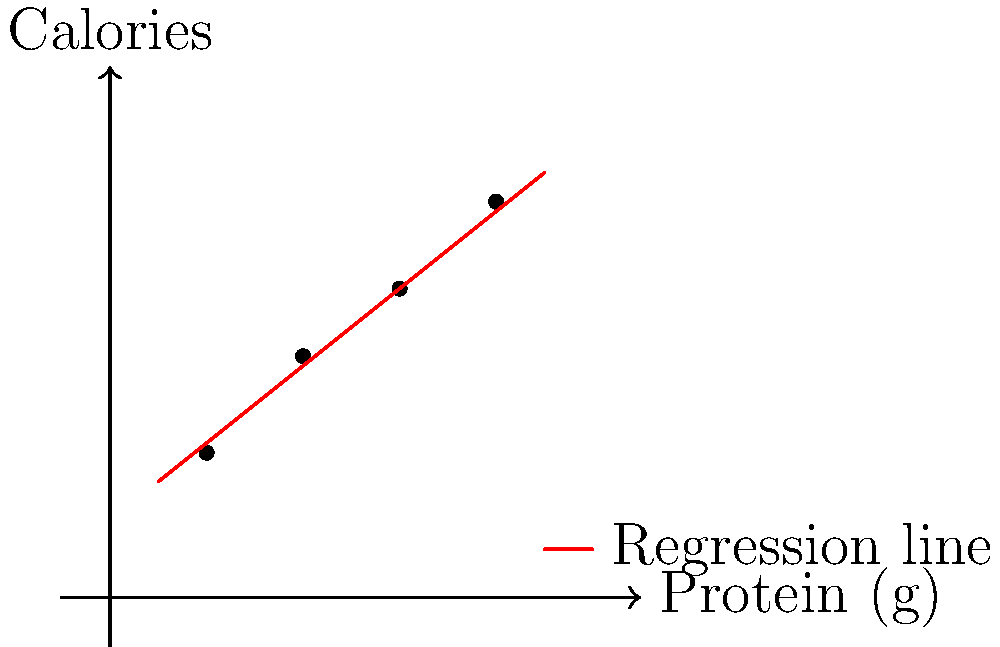Based on the scatter plot showing the relationship between protein content and calorie count in quick breakfast meals, if a new breakfast option contains 3.5g of protein, what would be its estimated calorie content according to the linear regression model? To estimate the calorie content for a breakfast with 3.5g of protein, we'll follow these steps:

1. Observe the linear relationship in the scatter plot.
2. Identify two points on the regression line:
   - At x=1, y≈1.5
   - At x=4, y≈4.1
3. Calculate the slope (m) of the regression line:
   $m = \frac{y_2 - y_1}{x_2 - x_1} = \frac{4.1 - 1.5}{4 - 1} = \frac{2.6}{3} ≈ 0.867$
4. Use the point-slope form of a line: $y - y_1 = m(x - x_1)$
   Using the point (1, 1.5): $y - 1.5 = 0.867(x - 1)$
5. Simplify to get the equation of the line:
   $y = 0.867x + 0.633$
6. Plug in x = 3.5 to estimate the calorie content:
   $y = 0.867(3.5) + 0.633 = 3.0345 + 0.633 = 3.6675$

Therefore, the estimated calorie content for a breakfast with 3.5g of protein is approximately 3.67 calories.
Answer: 3.67 calories 